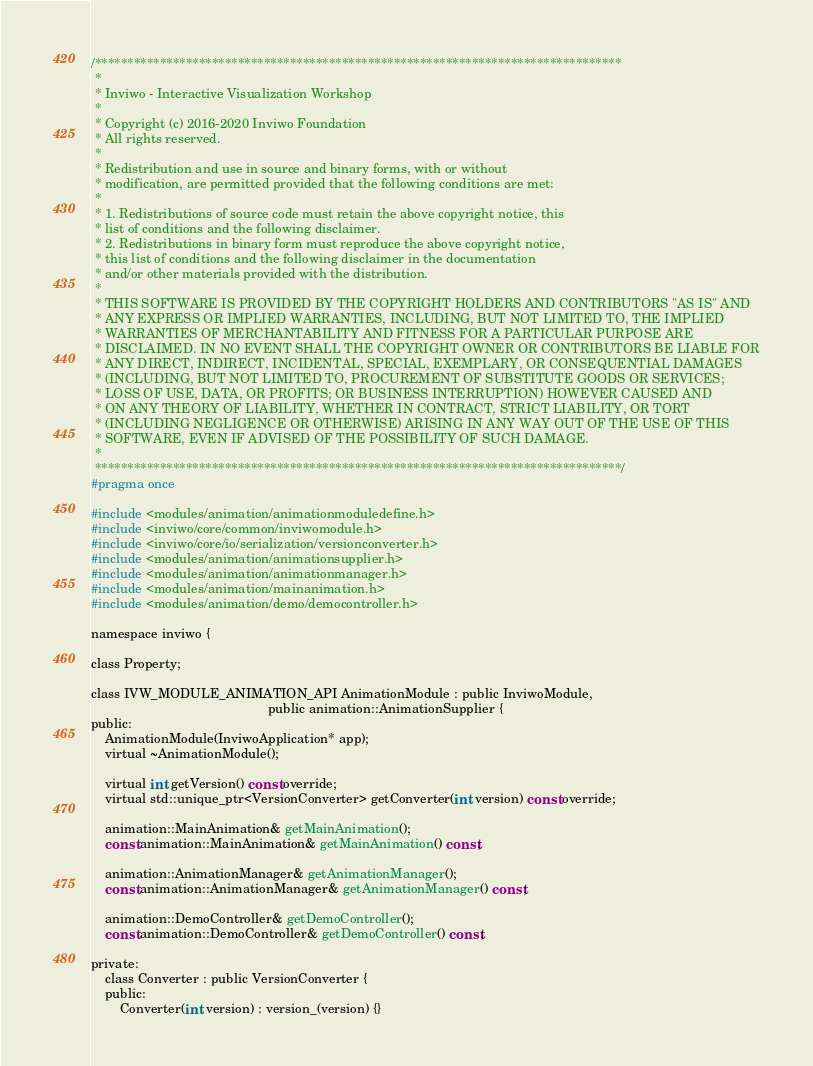Convert code to text. <code><loc_0><loc_0><loc_500><loc_500><_C_>/*********************************************************************************
 *
 * Inviwo - Interactive Visualization Workshop
 *
 * Copyright (c) 2016-2020 Inviwo Foundation
 * All rights reserved.
 *
 * Redistribution and use in source and binary forms, with or without
 * modification, are permitted provided that the following conditions are met:
 *
 * 1. Redistributions of source code must retain the above copyright notice, this
 * list of conditions and the following disclaimer.
 * 2. Redistributions in binary form must reproduce the above copyright notice,
 * this list of conditions and the following disclaimer in the documentation
 * and/or other materials provided with the distribution.
 *
 * THIS SOFTWARE IS PROVIDED BY THE COPYRIGHT HOLDERS AND CONTRIBUTORS "AS IS" AND
 * ANY EXPRESS OR IMPLIED WARRANTIES, INCLUDING, BUT NOT LIMITED TO, THE IMPLIED
 * WARRANTIES OF MERCHANTABILITY AND FITNESS FOR A PARTICULAR PURPOSE ARE
 * DISCLAIMED. IN NO EVENT SHALL THE COPYRIGHT OWNER OR CONTRIBUTORS BE LIABLE FOR
 * ANY DIRECT, INDIRECT, INCIDENTAL, SPECIAL, EXEMPLARY, OR CONSEQUENTIAL DAMAGES
 * (INCLUDING, BUT NOT LIMITED TO, PROCUREMENT OF SUBSTITUTE GOODS OR SERVICES;
 * LOSS OF USE, DATA, OR PROFITS; OR BUSINESS INTERRUPTION) HOWEVER CAUSED AND
 * ON ANY THEORY OF LIABILITY, WHETHER IN CONTRACT, STRICT LIABILITY, OR TORT
 * (INCLUDING NEGLIGENCE OR OTHERWISE) ARISING IN ANY WAY OUT OF THE USE OF THIS
 * SOFTWARE, EVEN IF ADVISED OF THE POSSIBILITY OF SUCH DAMAGE.
 *
 *********************************************************************************/
#pragma once

#include <modules/animation/animationmoduledefine.h>
#include <inviwo/core/common/inviwomodule.h>
#include <inviwo/core/io/serialization/versionconverter.h>
#include <modules/animation/animationsupplier.h>
#include <modules/animation/animationmanager.h>
#include <modules/animation/mainanimation.h>
#include <modules/animation/demo/democontroller.h>

namespace inviwo {

class Property;

class IVW_MODULE_ANIMATION_API AnimationModule : public InviwoModule,
                                                 public animation::AnimationSupplier {
public:
    AnimationModule(InviwoApplication* app);
    virtual ~AnimationModule();

    virtual int getVersion() const override;
    virtual std::unique_ptr<VersionConverter> getConverter(int version) const override;

    animation::MainAnimation& getMainAnimation();
    const animation::MainAnimation& getMainAnimation() const;

    animation::AnimationManager& getAnimationManager();
    const animation::AnimationManager& getAnimationManager() const;

    animation::DemoController& getDemoController();
    const animation::DemoController& getDemoController() const;

private:
    class Converter : public VersionConverter {
    public:
        Converter(int version) : version_(version) {}</code> 